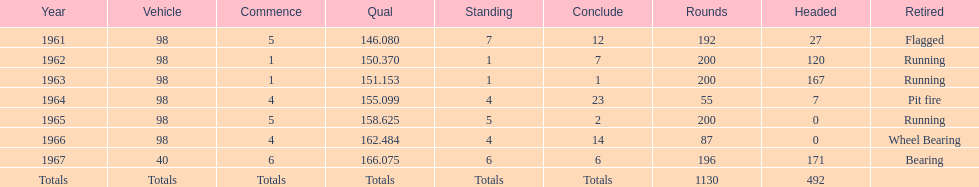Previous to 1965, when did jones have a number 5 start at the indy 500? 1961. 